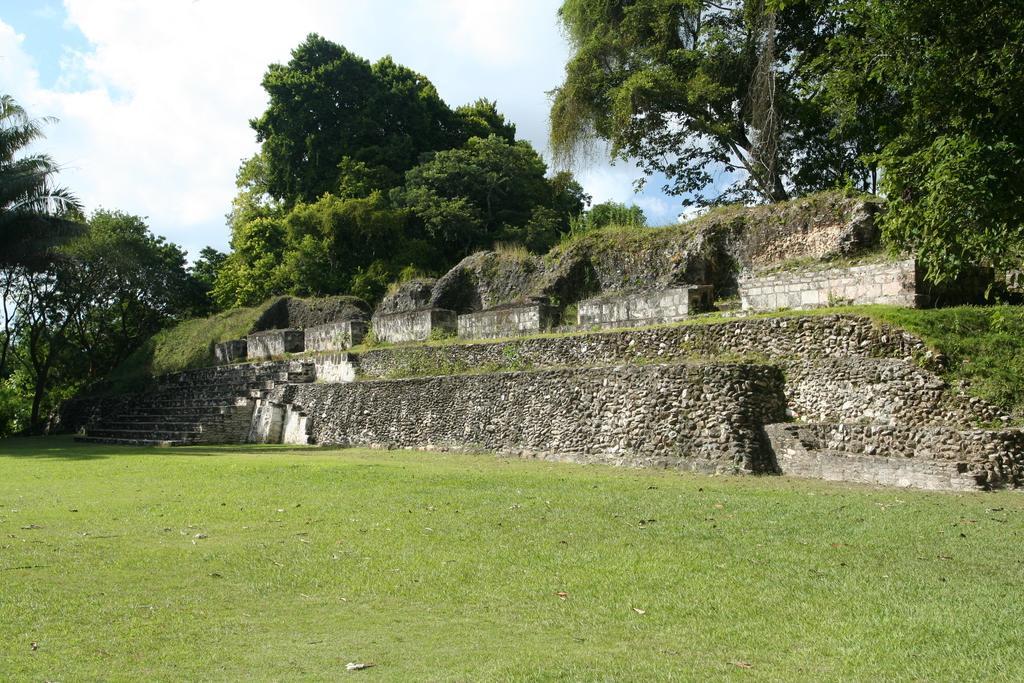In one or two sentences, can you explain what this image depicts? In this picture we can see the grass, walls, steps, trees and in the background we can see the sky. 